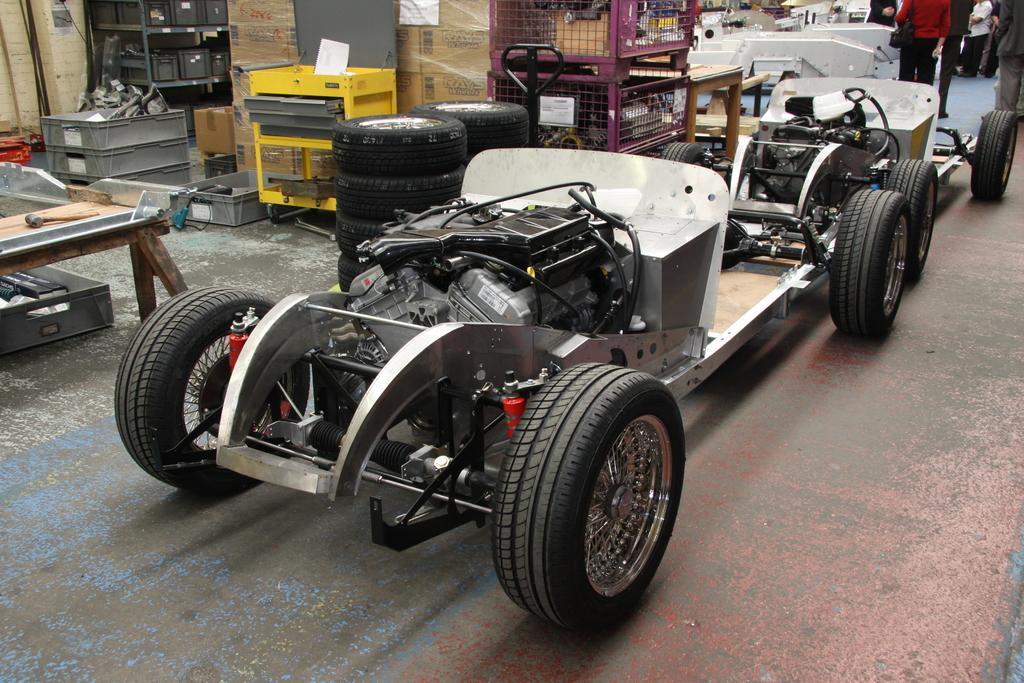In one or two sentences, can you explain what this image depicts? In the picture we can see a car in the service station with an engine and wheels attached to it and near to it, we can see some tables and some tool and near to it we can see some more trays with some tools. 